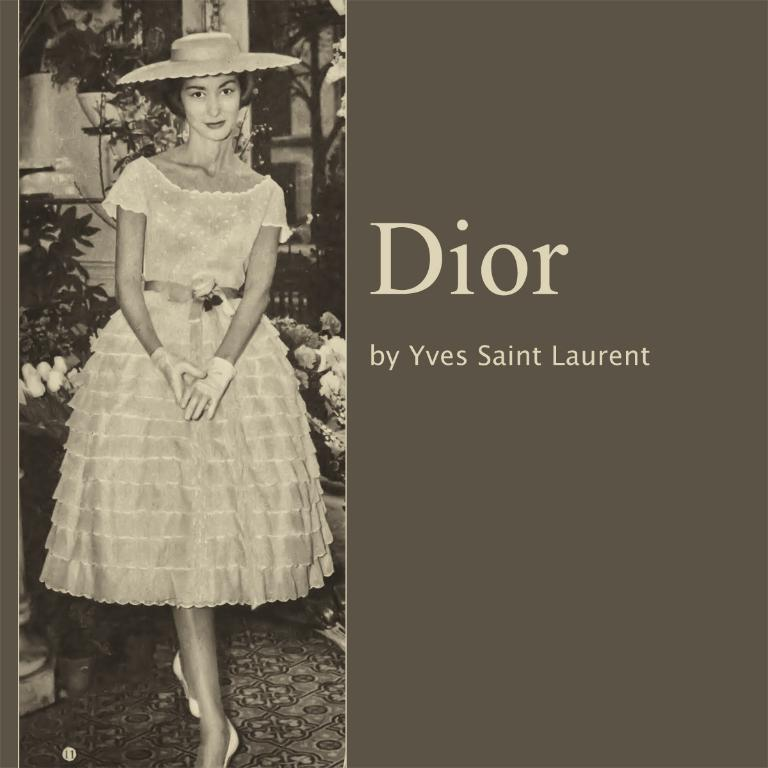Provide a one-sentence caption for the provided image. The album Dior produced by Yves Saint Laurent. 